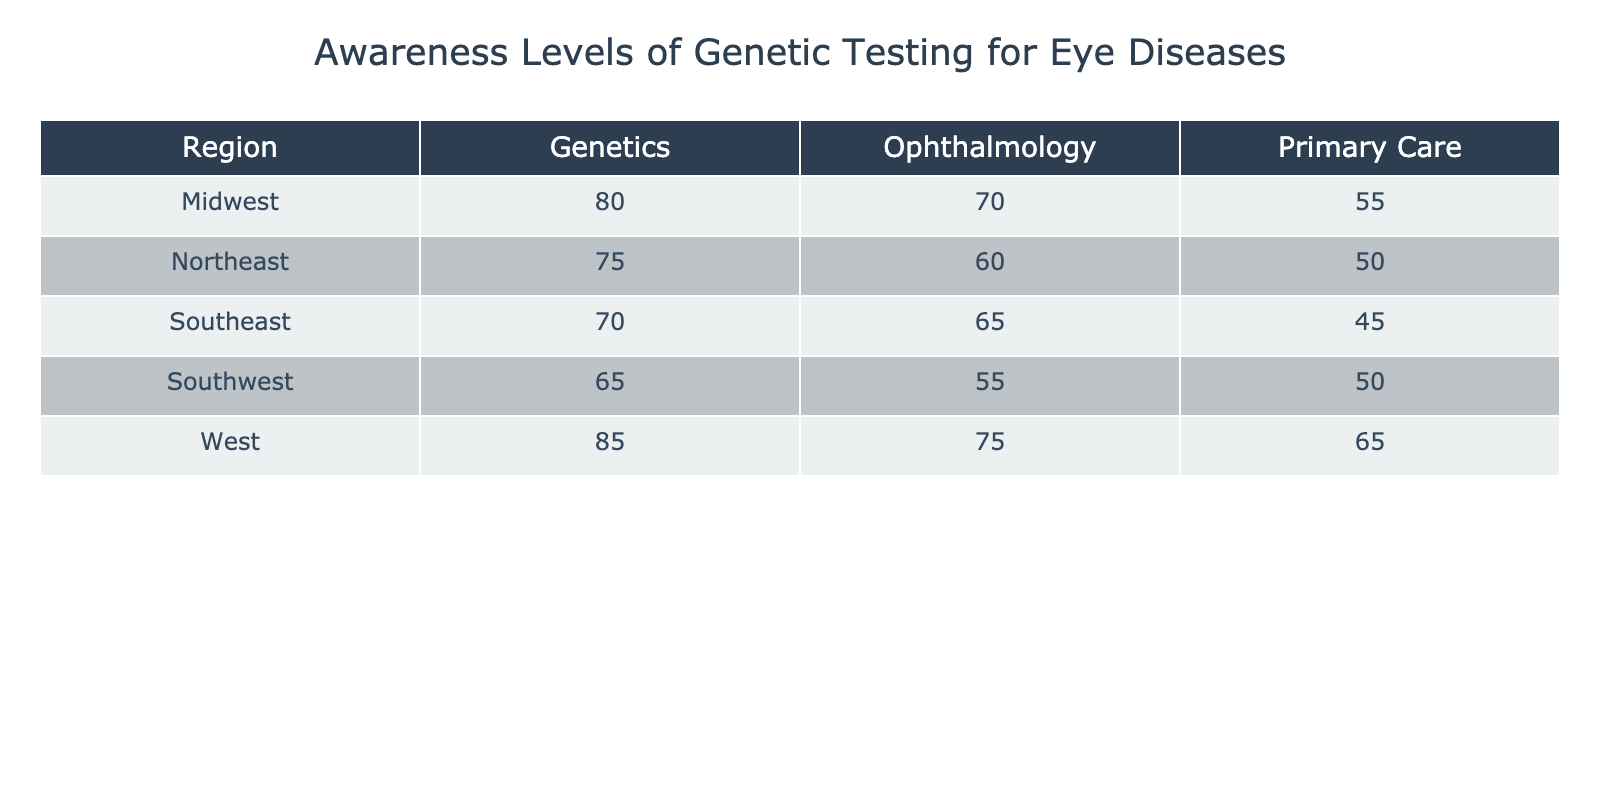What is the awareness level of genetic testing for eye diseases among ophthalmologists in the Northeast region? The table shows the awareness level for ophthalmologists in the Northeast as 60%. I can find this in the respective row and column intersecting in the table.
Answer: 60% Which region has the highest awareness level of genetic testing for genetics specialists? According to the table, the highest awareness level for genetics specialists is in the West at 85%. This can be determined by comparing the values across the regions for the genetics specialty.
Answer: 85% What is the average awareness level of genetic testing for all specialties in the Southeast region? The awareness levels for the Southeast region are 70%, 65%, and 45% for genetics, ophthalmology, and primary care, respectively. The average is calculated by summing these values (70 + 65 + 45) = 180, and dividing by the number of specialties (3). So, 180/3 = 60.
Answer: 60 Is the awareness level of genetic testing for eye diseases among primary care specialists in the Midwest higher than in the Northeast? The awareness level for primary care in the Midwest is 55%, while in the Northeast it is 50%. Therefore, the awareness level in the Midwest is indeed higher than that in the Northeast.
Answer: Yes What is the awareness level difference in genetic testing for eye diseases between genetics specialists in the Midwest and Southwest? The awareness level for genetics specialists in the Midwest is 80%, and in the Southwest, it is 65%. The difference is 80 - 65 = 15. This gives me the comparison between the two regions for the genetics specialty.
Answer: 15 In which specialty does the South region have the lowest awareness level? In the South region, the awareness levels are 65% for genetics, 55% for ophthalmology, and 50% for primary care. The lowest value is 50%, which corresponds to primary care. This allows us to determine the specialty with the least awareness in that region.
Answer: Primary Care What percentage of specialists in the West region have an awareness level of 70% or higher? The specialists in the West region are genetics (85%), ophthalmology (75%), and primary care (65%). The ones with 70% or higher are genetics and ophthalmology, which are 2 out of 3 specialists. Therefore, percentage calculation is (2/3)*100 = 66.67%. This helps in understanding the proportion of specialists with sufficient awareness in that region.
Answer: 66.67% Are ophthalmologists in the Midwest more aware of genetic testing for eye diseases compared to primary care providers in the same region? The awareness level for ophthalmologists in the Midwest is 70%, while for primary care providers, it is 55%. Thus, ophthalmologists are more aware of genetic testing than primary care providers in that region.
Answer: Yes 